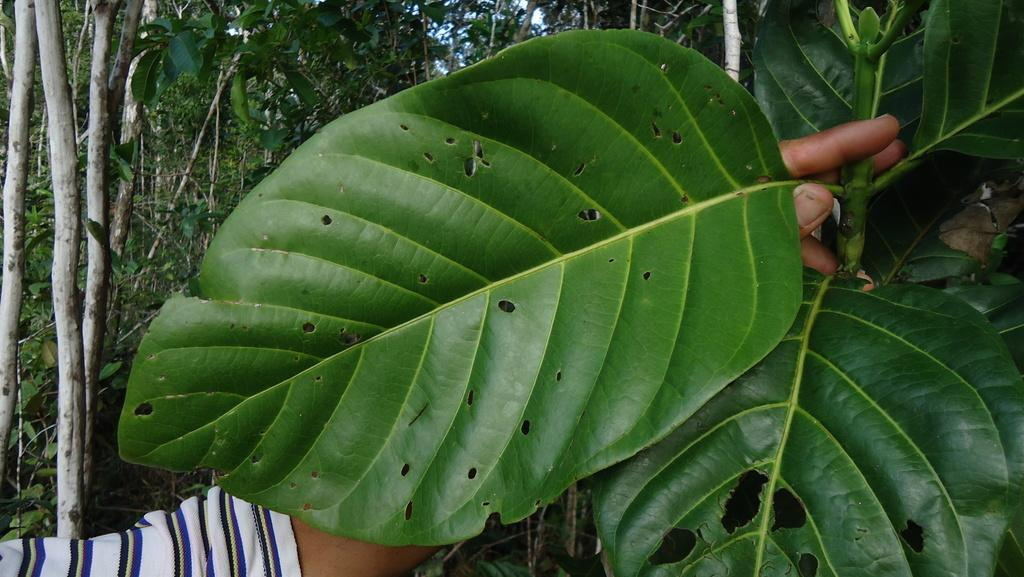What type of vegetation is on the right side of the image? There is a plant on the right side of the image. What is the person's hand doing in the image? A person's hand is holding a leaf in the image. What can be seen in the middle of the image? There are trees in the middle of the image. What type of fruit is the beast eating in the image? There is no beast or fruit present in the image; it features a plant, a person's hand holding a leaf, and trees. Where is the place located in the image? The term "place" is not mentioned in the provided facts, and therefore it cannot be located in the image. 